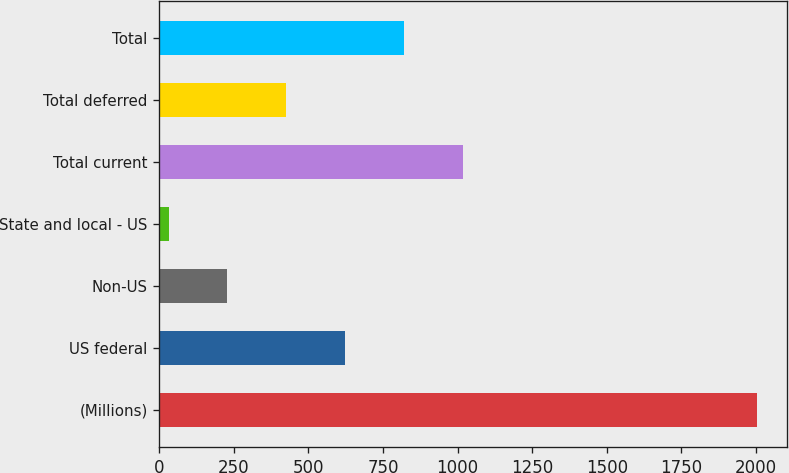Convert chart to OTSL. <chart><loc_0><loc_0><loc_500><loc_500><bar_chart><fcel>(Millions)<fcel>US federal<fcel>Non-US<fcel>State and local - US<fcel>Total current<fcel>Total deferred<fcel>Total<nl><fcel>2005<fcel>623.2<fcel>228.4<fcel>31<fcel>1018<fcel>425.8<fcel>820.6<nl></chart> 